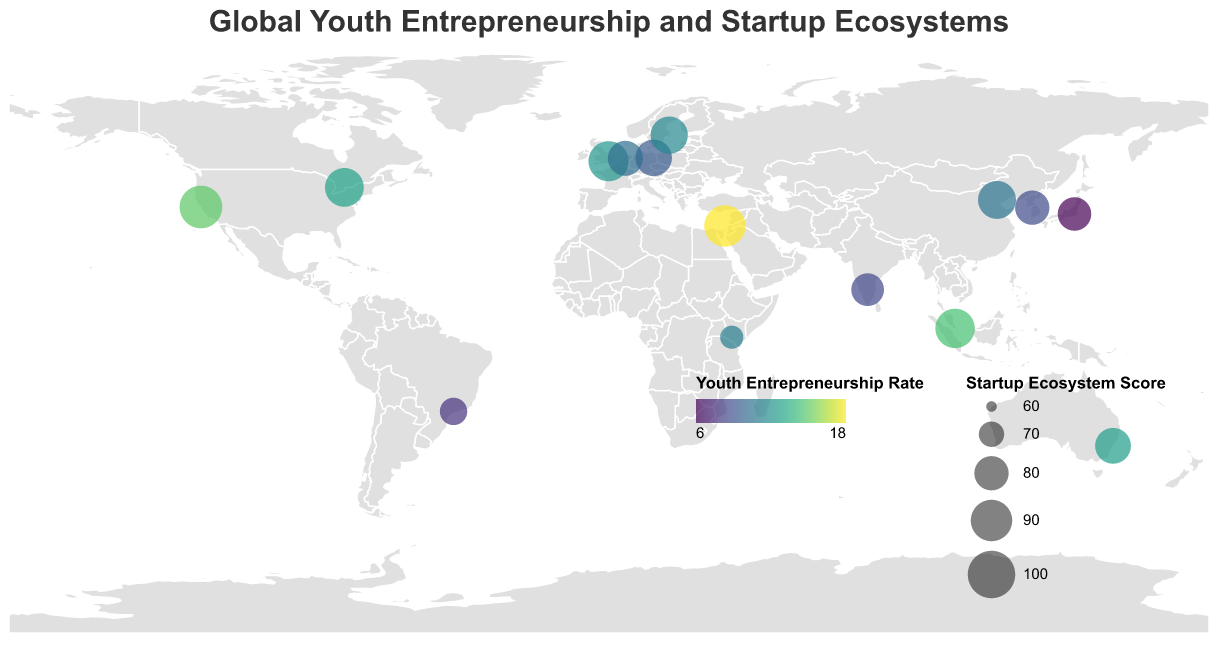What is the title of the plot? The title is given at the top of the plot and clearly states the overall theme of the data being visualized.
Answer: Global Youth Entrepreneurship and Startup Ecosystems Which country has the highest Youth Entrepreneurship Rate? By looking at the color scale on the map, which reflects the Youth Entrepreneurship Rate, the country with the darkest color represents the highest rate. This color corresponds to Israel.
Answer: Israel Which country has the highest Startup Ecosystem Score? Startup Ecosystem Score is depicted through the size of the circles on the map. The largest circle will represent the highest score, which belongs to the United States with a score of 92.
Answer: United States Which country has the lowest Youth Entrepreneurship Rate, and what is its Top Startup City? The country with the lightest color on the map, indicating the lowest Youth Entrepreneurship Rate, is Japan. The Top Startup City in Japan is Tokyo.
Answer: Japan, Tokyo What is the average Youth Entrepreneurship Rate across all the countries shown? Sum all Youth Entrepreneurship Rates and divide by the number of countries: (15.2 + 10.8 + 8.7 + 12.5 + 9.6 + 18.3 + 14.7 + 7.9 + 11.3 + 13.1 + 11.8 + 6.2 + 12.9 + 10.5 + 8.9) / 15 = 11.4
Answer: 11.4 How does the Youth Entrepreneurship Rate in Israel compare to Brazil? The Youth Entrepreneurship Rate in Israel (18.3) is significantly higher than that of Brazil (7.9).
Answer: Israel's rate is higher Which country has the largest circle but a lower Youth Entrepreneurship Rate than the United Kingdom? This requires identifying a large circle (high Startup Ecosystem Score) and comparing Youth Entrepreneurship Rates. China has a large circle (score of 85) but a lower rate (10.8) than the UK's 12.5.
Answer: China Find the country with the closest Youth Entrepreneurship Rate to the global average and name its Top Startup City. The average rate is 11.4. The rates close to this value are Sweden (11.8), Kenya (11.3), and the UK (12.5). Kenya's Youth Entrepreneurship Rate of 11.3 is closest. Its Top Startup City is Nairobi.
Answer: Kenya, Nairobi Which country is represented by the smallest circle, and what is its Startup Ecosystem Score? The smallest circle indicates the lowest Startup Ecosystem Score. Kenya has the smallest circle, with a score of 68.
Answer: Kenya, 68 